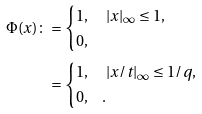<formula> <loc_0><loc_0><loc_500><loc_500>\Phi ( x ) \colon & = \begin{cases} 1 , & \ | x | _ { \infty } \leq 1 , \\ 0 , & \end{cases} \\ & = \begin{cases} 1 , & \ | x / t | _ { \infty } \leq 1 / q , \\ 0 , & . \end{cases}</formula> 